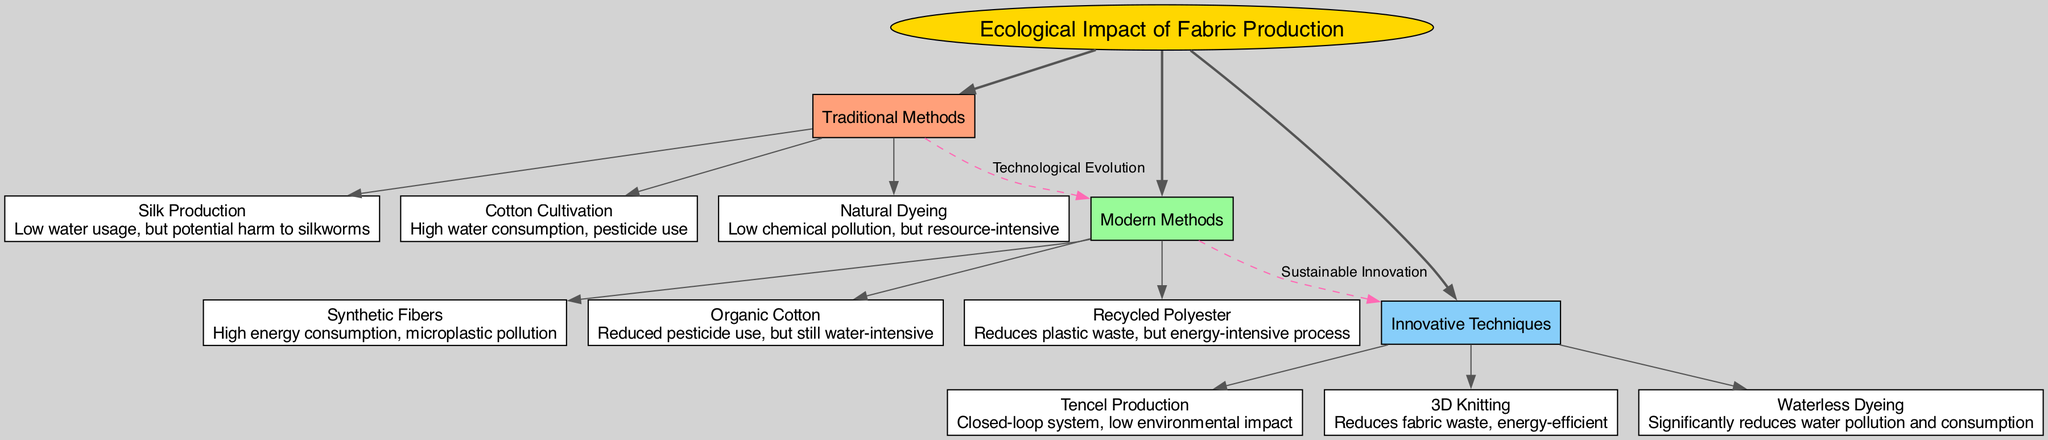What are the three main branches of fabric production methods? The diagram identifies three main branches under the central topic: Traditional Methods, Modern Methods, and Innovative Techniques.
Answer: Traditional Methods, Modern Methods, Innovative Techniques How many sub-branches does the category "Modern Methods" have? Under the category "Modern Methods," there are three sub-branches: Synthetic Fibers, Organic Cotton, and Recycled Polyester.
Answer: Three What is the ecological impact of Silk Production? According to the diagram, the ecological impact of Silk Production is described as "Low water usage, but potential harm to silkworms."
Answer: Low water usage, but potential harm to silkworms Which modern method has a connection to Innovative Techniques? The diagram shows that Modern Methods lead to Innovative Techniques through a connection labeled "Sustainable Innovation."
Answer: All three: Synthetic Fibers, Organic Cotton, Recycled Polyester Which production method has significantly reduced water pollution and consumption? The diagram indicates that Waterless Dyeing is associated with significantly reducing water pollution and consumption.
Answer: Waterless Dyeing What does Tencel Production utilize to minimize environmental impact? The diagram describes Tencel Production as having a "Closed-loop system, low environmental impact," which suggests the method is designed to minimize waste and resource use.
Answer: Closed-loop system Which traditional method has the highest environmental concern due to water? The diagram indicates that Cotton Cultivation has high water consumption and pesticide use, making it a concern in traditional methods.
Answer: Cotton Cultivation Which connection illustrates the evolution of fabric production techniques? The connection labeled "Technological Evolution" between Traditional Methods and Modern Methods illustrates how fabric production techniques have progressed over time.
Answer: Technological Evolution How are innovative techniques related to modern methods in terms of sustainability? The diagram connects Innovative Techniques to Modern Methods with a label "Sustainable Innovation," pointing towards advancements aimed at improving sustainability in fabric production.
Answer: Sustainable Innovation 